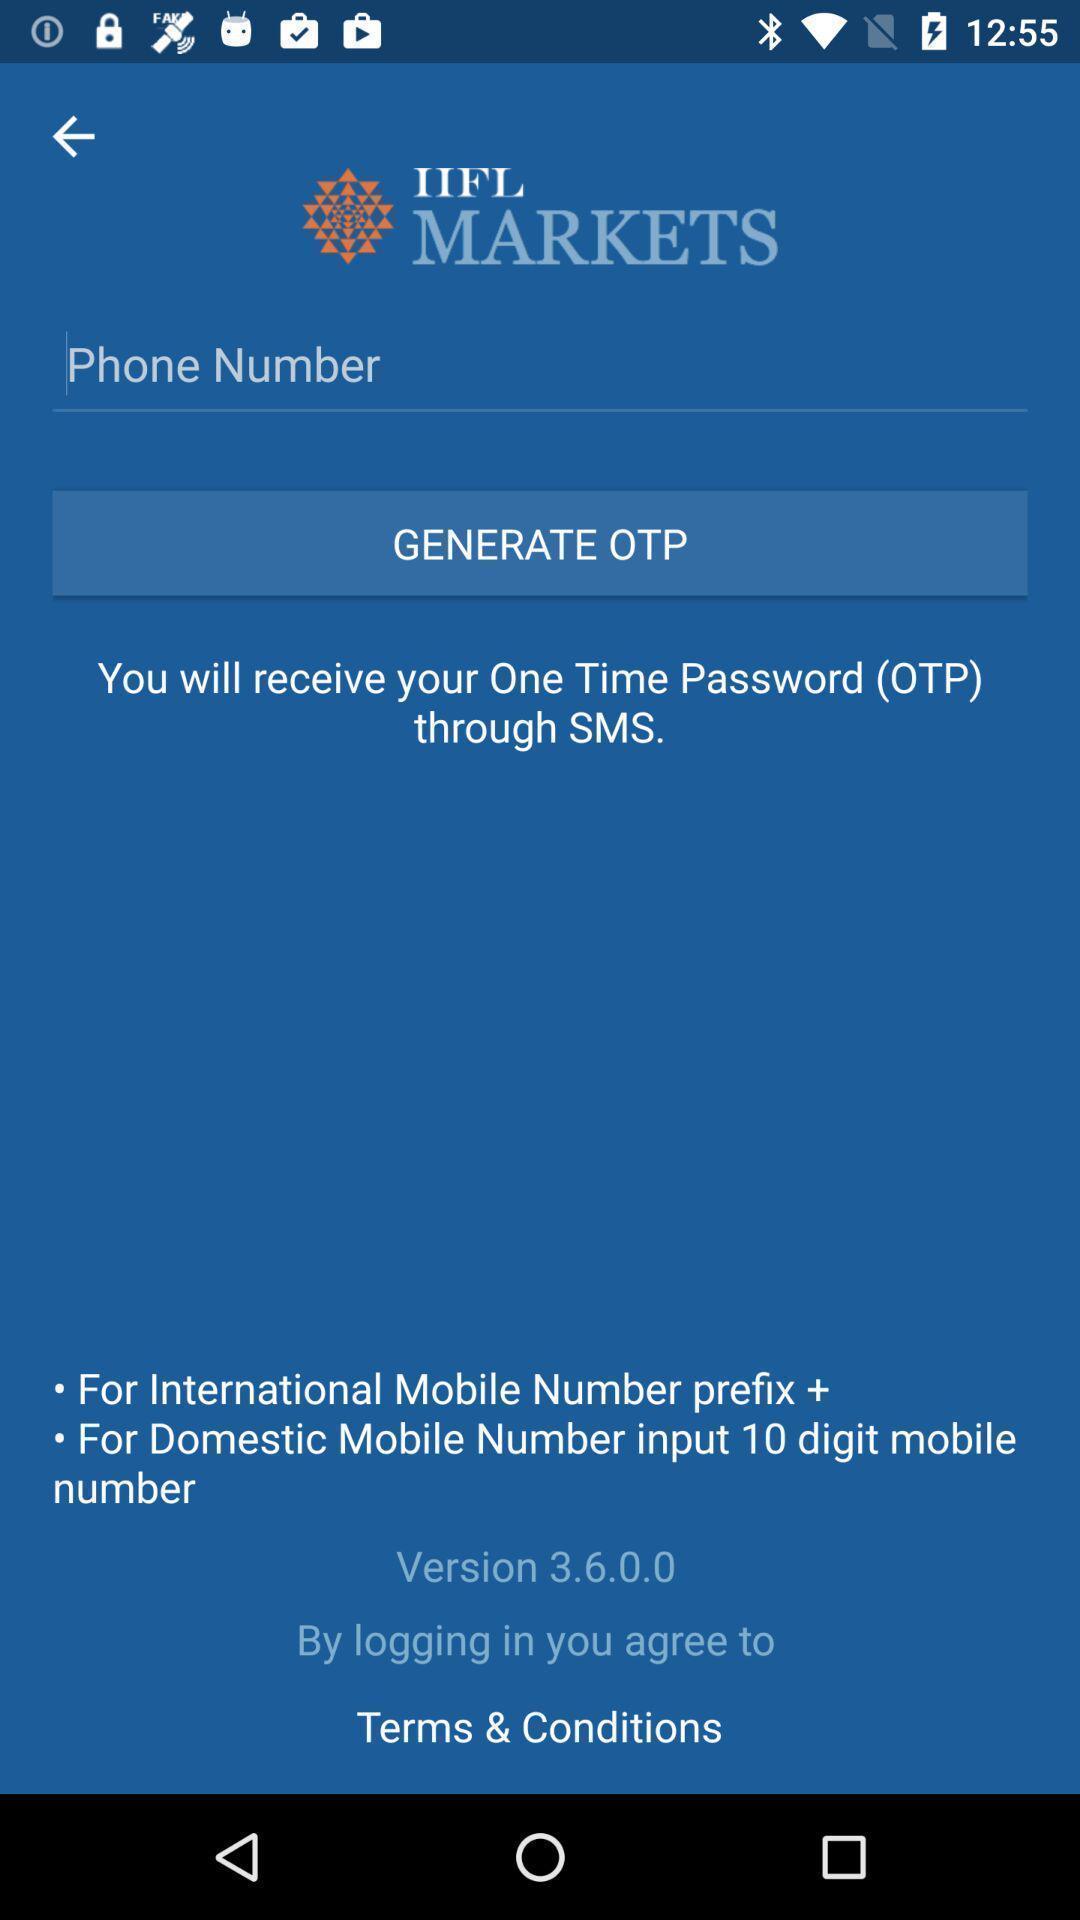Give me a summary of this screen capture. Screen shows add phone number details in a finance app. 